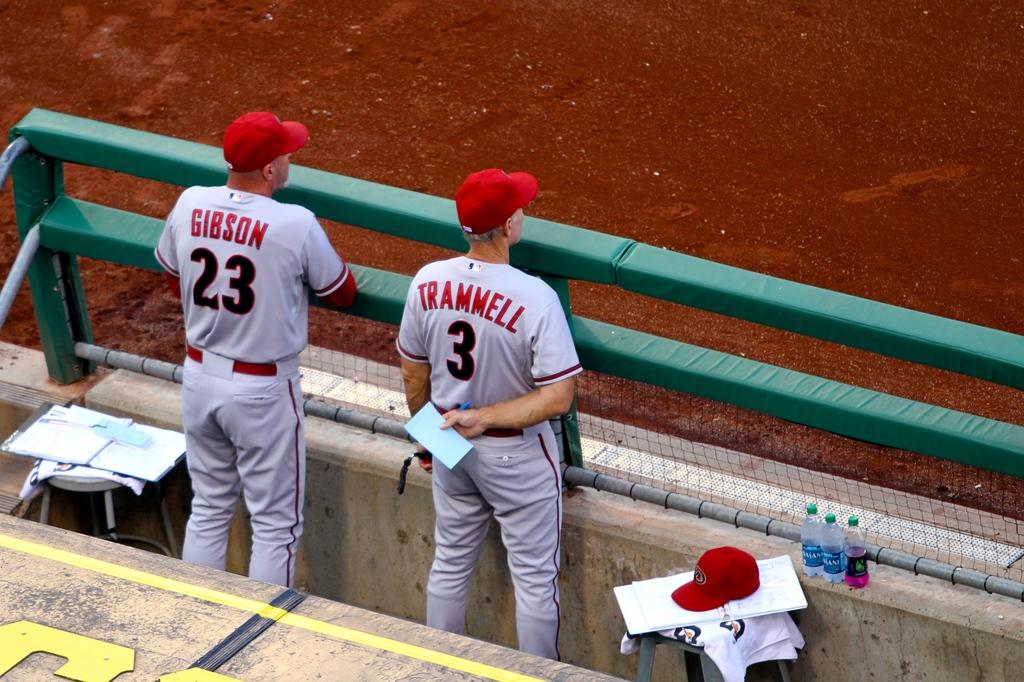Provide a one-sentence caption for the provided image. Baseball coaches wearing number 3 and 23 observe the game from the dugout. 